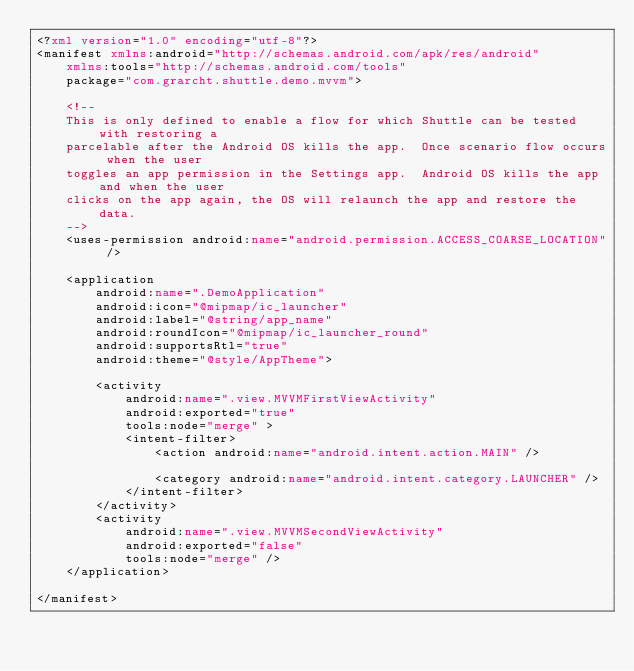<code> <loc_0><loc_0><loc_500><loc_500><_XML_><?xml version="1.0" encoding="utf-8"?>
<manifest xmlns:android="http://schemas.android.com/apk/res/android"
    xmlns:tools="http://schemas.android.com/tools"
    package="com.grarcht.shuttle.demo.mvvm">

    <!--
    This is only defined to enable a flow for which Shuttle can be tested with restoring a
    parcelable after the Android OS kills the app.  Once scenario flow occurs when the user
    toggles an app permission in the Settings app.  Android OS kills the app and when the user
    clicks on the app again, the OS will relaunch the app and restore the data.
    -->
    <uses-permission android:name="android.permission.ACCESS_COARSE_LOCATION" />

    <application
        android:name=".DemoApplication"
        android:icon="@mipmap/ic_launcher"
        android:label="@string/app_name"
        android:roundIcon="@mipmap/ic_launcher_round"
        android:supportsRtl="true"
        android:theme="@style/AppTheme">

        <activity
            android:name=".view.MVVMFirstViewActivity"
            android:exported="true"
            tools:node="merge" >
            <intent-filter>
                <action android:name="android.intent.action.MAIN" />

                <category android:name="android.intent.category.LAUNCHER" />
            </intent-filter>
        </activity>
        <activity
            android:name=".view.MVVMSecondViewActivity"
            android:exported="false"
            tools:node="merge" />
    </application>

</manifest></code> 